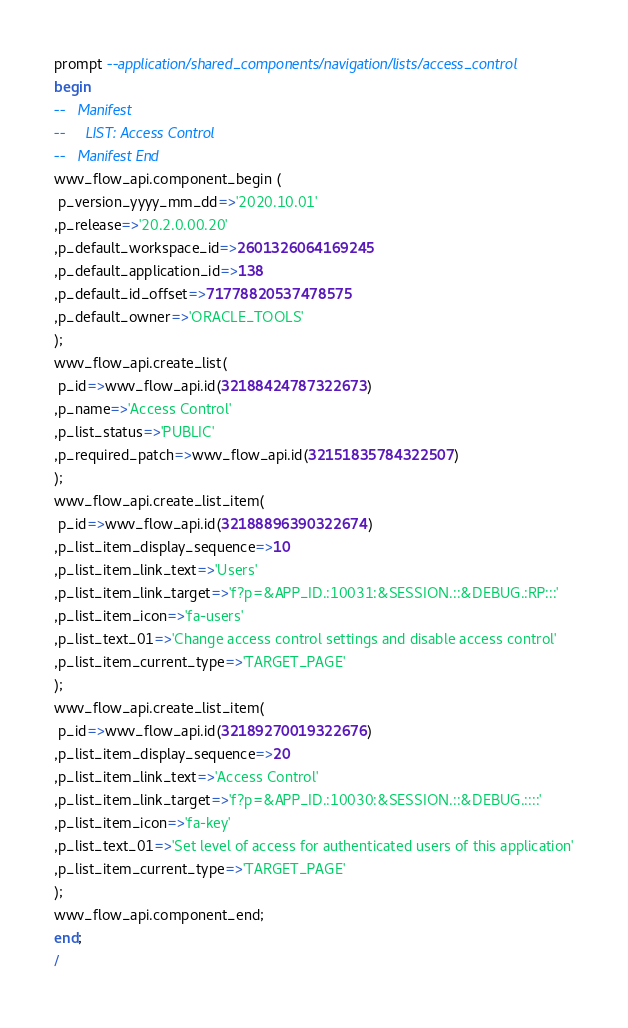<code> <loc_0><loc_0><loc_500><loc_500><_SQL_>prompt --application/shared_components/navigation/lists/access_control
begin
--   Manifest
--     LIST: Access Control
--   Manifest End
wwv_flow_api.component_begin (
 p_version_yyyy_mm_dd=>'2020.10.01'
,p_release=>'20.2.0.00.20'
,p_default_workspace_id=>2601326064169245
,p_default_application_id=>138
,p_default_id_offset=>71778820537478575
,p_default_owner=>'ORACLE_TOOLS'
);
wwv_flow_api.create_list(
 p_id=>wwv_flow_api.id(32188424787322673)
,p_name=>'Access Control'
,p_list_status=>'PUBLIC'
,p_required_patch=>wwv_flow_api.id(32151835784322507)
);
wwv_flow_api.create_list_item(
 p_id=>wwv_flow_api.id(32188896390322674)
,p_list_item_display_sequence=>10
,p_list_item_link_text=>'Users'
,p_list_item_link_target=>'f?p=&APP_ID.:10031:&SESSION.::&DEBUG.:RP:::'
,p_list_item_icon=>'fa-users'
,p_list_text_01=>'Change access control settings and disable access control'
,p_list_item_current_type=>'TARGET_PAGE'
);
wwv_flow_api.create_list_item(
 p_id=>wwv_flow_api.id(32189270019322676)
,p_list_item_display_sequence=>20
,p_list_item_link_text=>'Access Control'
,p_list_item_link_target=>'f?p=&APP_ID.:10030:&SESSION.::&DEBUG.::::'
,p_list_item_icon=>'fa-key'
,p_list_text_01=>'Set level of access for authenticated users of this application'
,p_list_item_current_type=>'TARGET_PAGE'
);
wwv_flow_api.component_end;
end;
/
</code> 